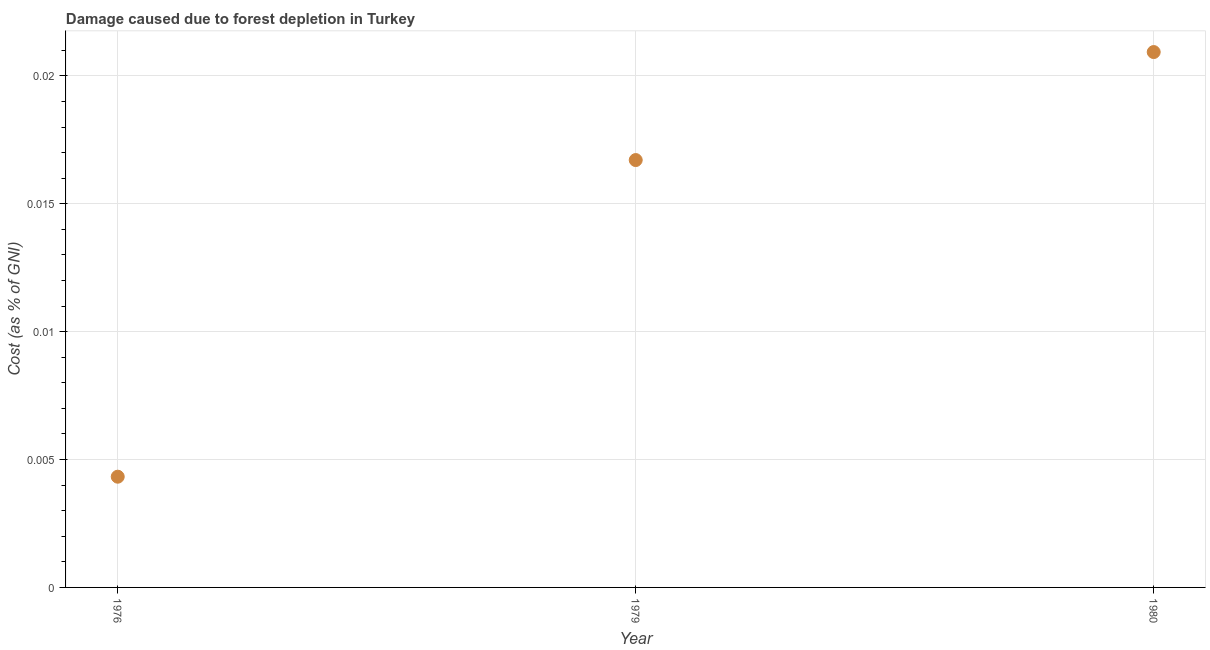What is the damage caused due to forest depletion in 1980?
Give a very brief answer. 0.02. Across all years, what is the maximum damage caused due to forest depletion?
Provide a succinct answer. 0.02. Across all years, what is the minimum damage caused due to forest depletion?
Offer a terse response. 0. In which year was the damage caused due to forest depletion minimum?
Make the answer very short. 1976. What is the sum of the damage caused due to forest depletion?
Offer a terse response. 0.04. What is the difference between the damage caused due to forest depletion in 1976 and 1979?
Make the answer very short. -0.01. What is the average damage caused due to forest depletion per year?
Offer a terse response. 0.01. What is the median damage caused due to forest depletion?
Your answer should be compact. 0.02. In how many years, is the damage caused due to forest depletion greater than 0.003 %?
Keep it short and to the point. 3. Do a majority of the years between 1976 and 1979 (inclusive) have damage caused due to forest depletion greater than 0.009000000000000001 %?
Offer a very short reply. No. What is the ratio of the damage caused due to forest depletion in 1976 to that in 1979?
Your response must be concise. 0.26. Is the damage caused due to forest depletion in 1976 less than that in 1980?
Ensure brevity in your answer.  Yes. Is the difference between the damage caused due to forest depletion in 1976 and 1980 greater than the difference between any two years?
Offer a terse response. Yes. What is the difference between the highest and the second highest damage caused due to forest depletion?
Ensure brevity in your answer.  0. Is the sum of the damage caused due to forest depletion in 1979 and 1980 greater than the maximum damage caused due to forest depletion across all years?
Your answer should be compact. Yes. What is the difference between the highest and the lowest damage caused due to forest depletion?
Offer a very short reply. 0.02. Does the damage caused due to forest depletion monotonically increase over the years?
Your answer should be very brief. Yes. How many dotlines are there?
Your response must be concise. 1. What is the difference between two consecutive major ticks on the Y-axis?
Ensure brevity in your answer.  0.01. Are the values on the major ticks of Y-axis written in scientific E-notation?
Your response must be concise. No. Does the graph contain grids?
Provide a succinct answer. Yes. What is the title of the graph?
Keep it short and to the point. Damage caused due to forest depletion in Turkey. What is the label or title of the Y-axis?
Your response must be concise. Cost (as % of GNI). What is the Cost (as % of GNI) in 1976?
Provide a succinct answer. 0. What is the Cost (as % of GNI) in 1979?
Offer a very short reply. 0.02. What is the Cost (as % of GNI) in 1980?
Your answer should be compact. 0.02. What is the difference between the Cost (as % of GNI) in 1976 and 1979?
Keep it short and to the point. -0.01. What is the difference between the Cost (as % of GNI) in 1976 and 1980?
Make the answer very short. -0.02. What is the difference between the Cost (as % of GNI) in 1979 and 1980?
Your answer should be very brief. -0. What is the ratio of the Cost (as % of GNI) in 1976 to that in 1979?
Offer a very short reply. 0.26. What is the ratio of the Cost (as % of GNI) in 1976 to that in 1980?
Your answer should be compact. 0.21. What is the ratio of the Cost (as % of GNI) in 1979 to that in 1980?
Offer a terse response. 0.8. 